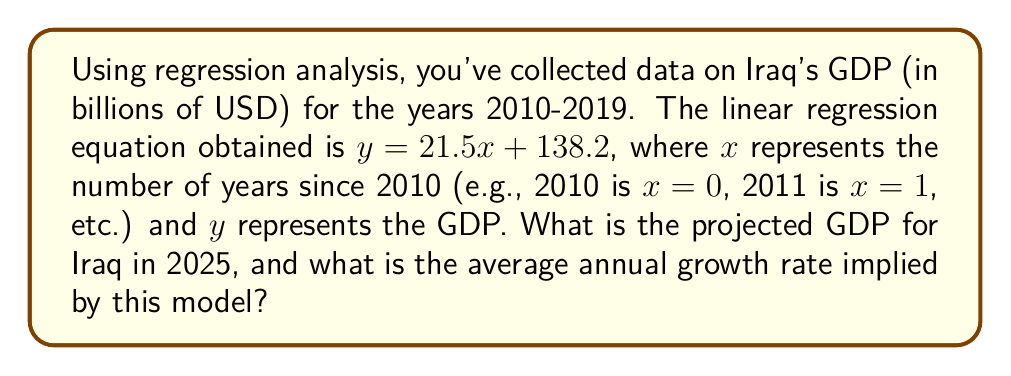Can you solve this math problem? To solve this problem, we'll follow these steps:

1. Calculate the projected GDP for 2025:
   - 2025 is 15 years after 2010, so $x = 15$
   - Substitute $x = 15$ into the equation: $y = 21.5(15) + 138.2$
   - $y = 322.5 + 138.2 = 460.7$

2. Calculate the average annual growth rate:
   - The slope of the line, 21.5, represents the average annual increase in GDP
   - To find the growth rate, we need to compare this to the initial GDP (when $x = 0$)
   - Initial GDP: $y = 21.5(0) + 138.2 = 138.2$ billion USD
   - Growth rate = $\frac{\text{Annual increase}}{\text{Initial value}} \times 100\%$
   - Growth rate = $\frac{21.5}{138.2} \times 100\% \approx 15.56\%$

Therefore, the projected GDP for Iraq in 2025 is 460.7 billion USD, and the average annual growth rate implied by this model is approximately 15.56%.
Answer: Projected GDP for Iraq in 2025: $460.7 billion USD
Average annual growth rate: $15.56\%$ 